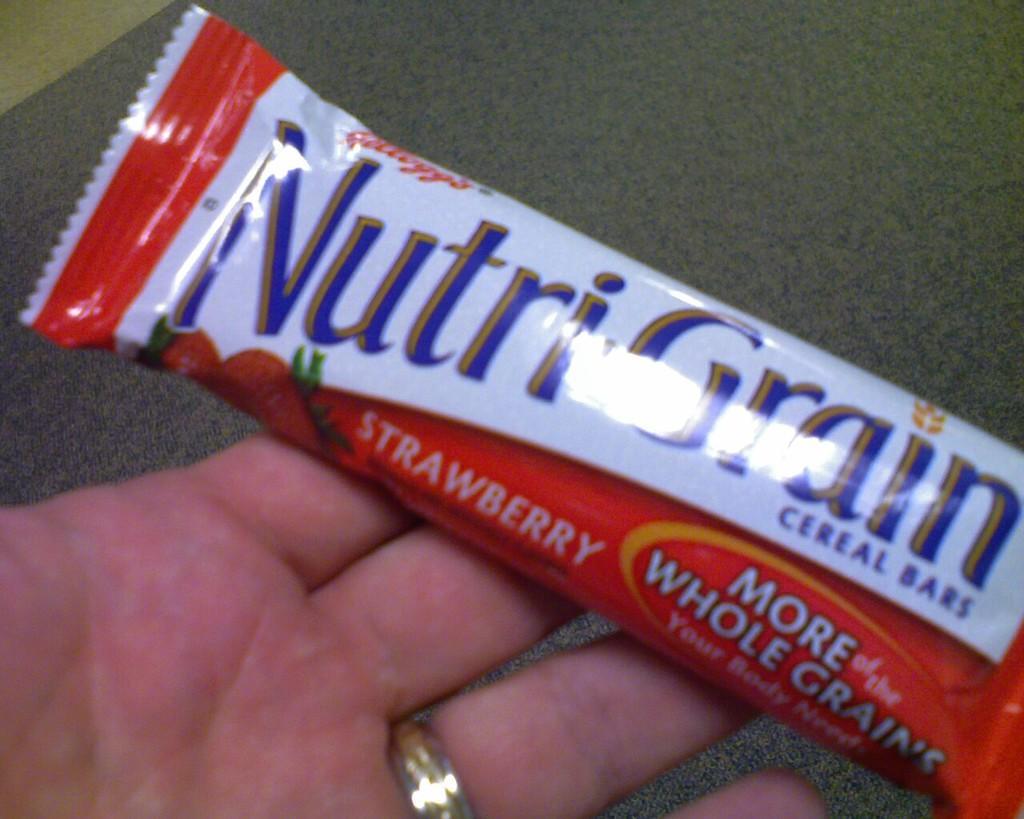Could you give a brief overview of what you see in this image? In this image we can see a chocolate in a person's hand. At the bottom of the image there is carpet. 